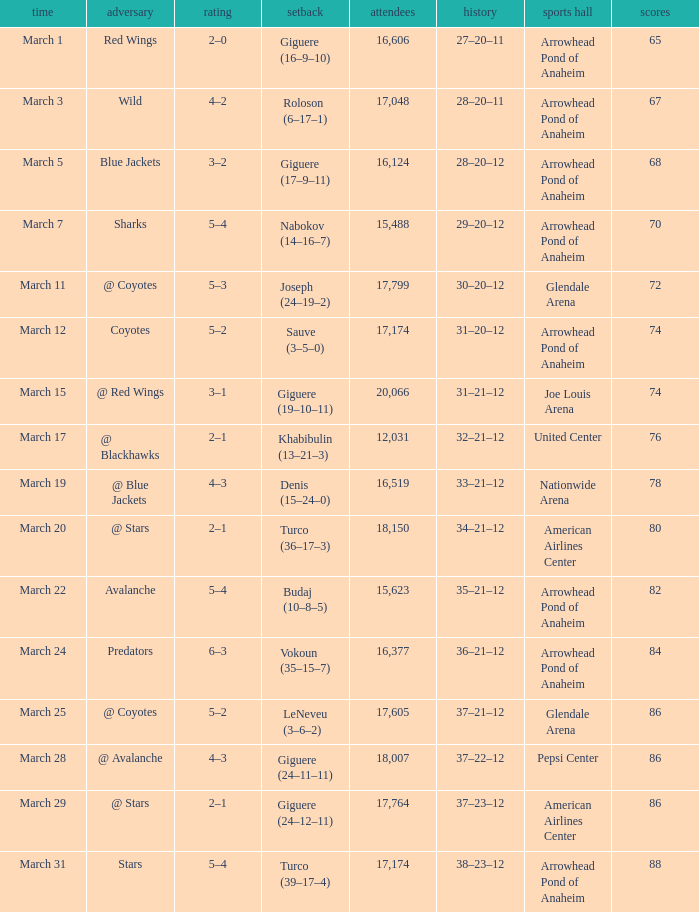What is the Score of the game on March 19? 4–3. 